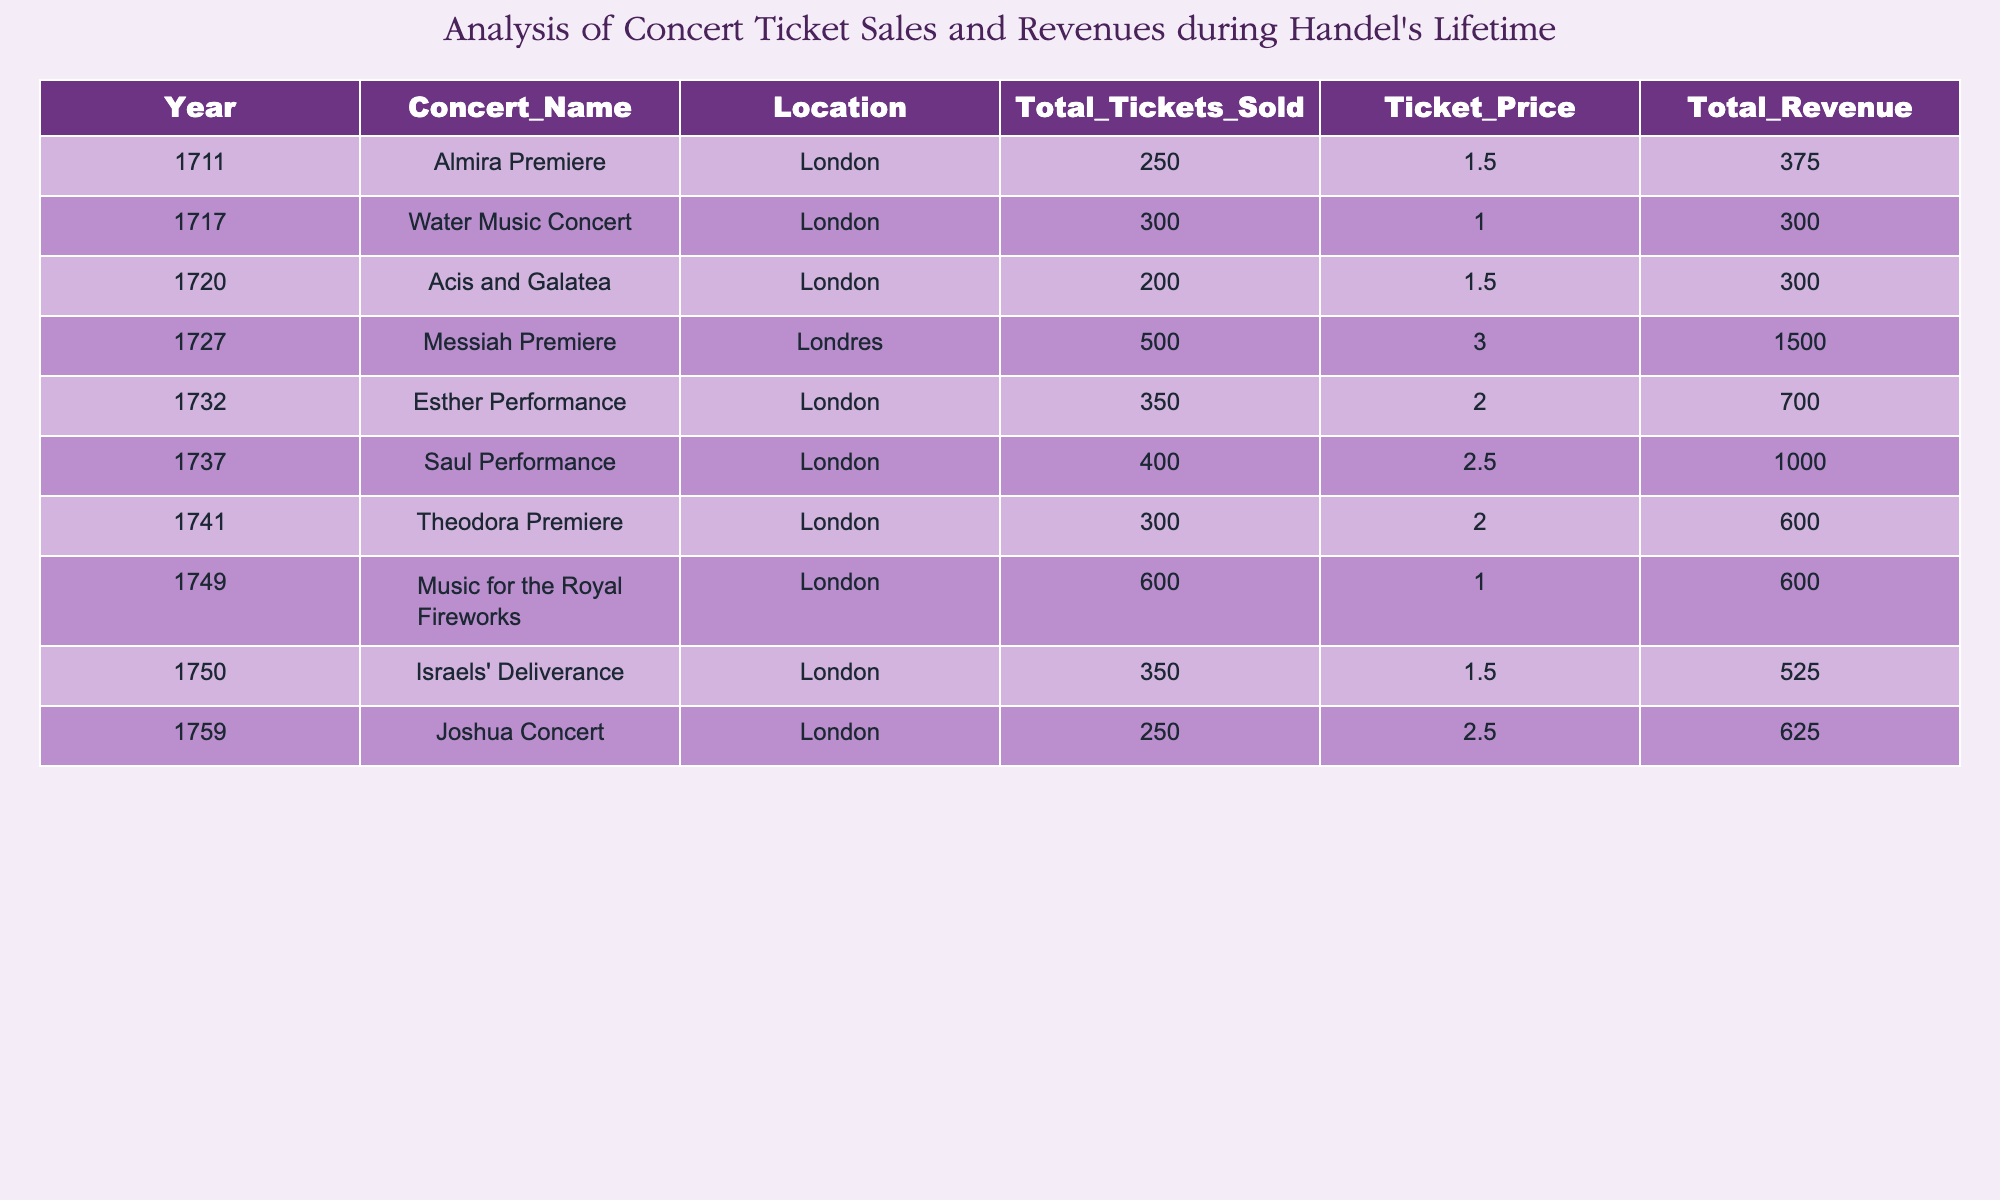What was the total revenue generated from the "Messiah Premiere"? By looking at the row for "Messiah Premiere," I can see that the Total Revenue is listed as 1500.
Answer: 1500 In what year did the "Water Music Concert" take place? The "Water Music Concert" is listed under the year 1717 in the table.
Answer: 1717 What was the average ticket price across all concerts listed? To find the average ticket price, I add all the ticket prices (1.5 + 1.0 + 1.5 + 3.0 + 2.0 + 2.5 + 2.0 + 1.0 + 1.5 + 2.5 = 17.5) and divide by the number of concerts (10). Therefore, the average ticket price is 17.5/10 = 1.75.
Answer: 1.75 Did more than 400 tickets sell for the "Saul Performance"? The table shows that the "Saul Performance" sold a total of 400 tickets. Therefore, the answer is no, as it did not exceed 400 tickets sold.
Answer: No Which concert had the highest total revenue, and what was that revenue? I will look through all the concerts and compare the Total Revenue values: "Messiah Premiere" has the highest at 1500. Thus, the concert that had the highest total revenue is the "Messiah Premiere" with 1500.
Answer: Messiah Premiere; 1500 What is the difference in total tickets sold between the "Almira Premiere" and the "Israels' Deliverance"? "Almira Premiere" sold 250 total tickets and "Israels' Deliverance" sold 350 total tickets. The difference is 350 - 250 = 100.
Answer: 100 Which concert had the least total revenue, and how much was it? I will analyze the Total Revenue for each concert and find that the "Water Music Concert" had the least revenue at 300.
Answer: Water Music Concert; 300 How many concerts sold more than 500 tickets? I will count the concerts that have Total Tickets Sold greater than 500. According to the table, "Music for the Royal Fireworks" is the only concert that sold more than 500 tickets. Therefore, the answer is 1.
Answer: 1 